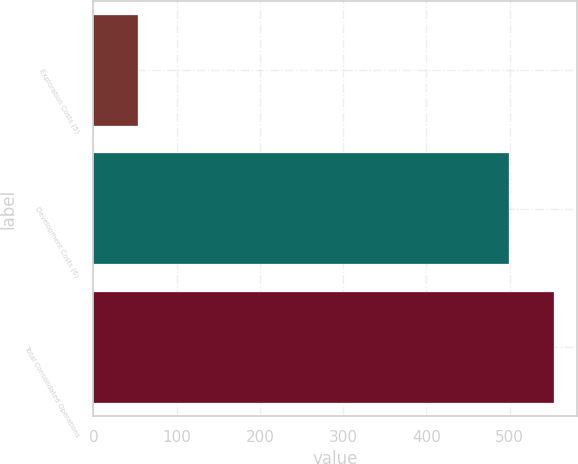Convert chart to OTSL. <chart><loc_0><loc_0><loc_500><loc_500><bar_chart><fcel>Exploration Costs (5)<fcel>Development Costs (6)<fcel>Total Consolidated Operations<nl><fcel>54<fcel>499<fcel>553<nl></chart> 